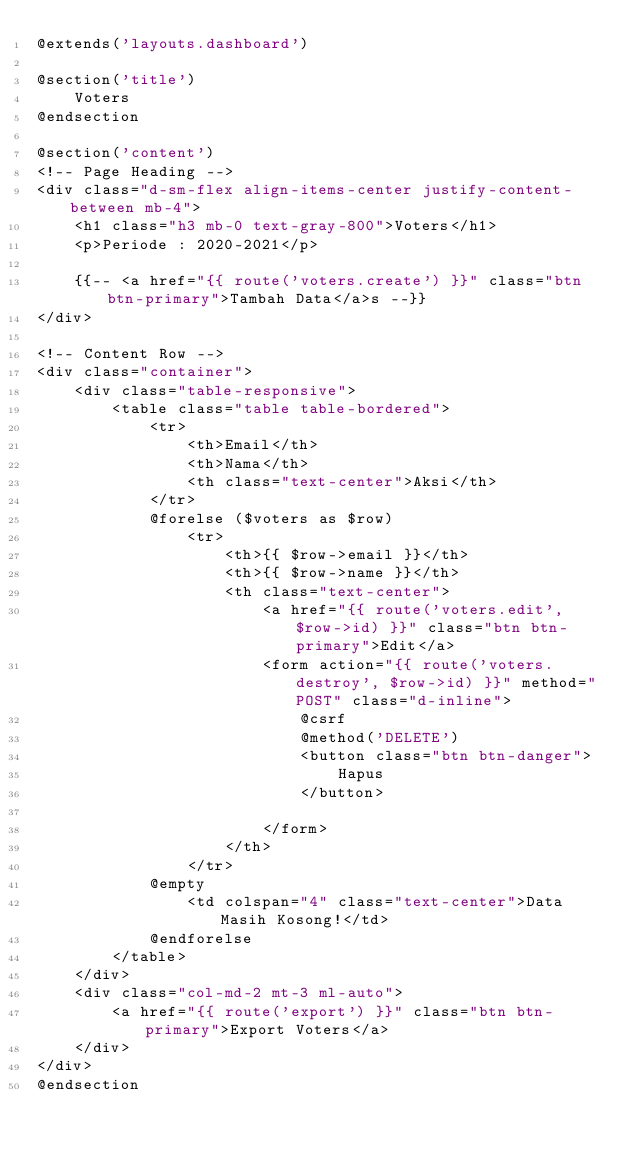<code> <loc_0><loc_0><loc_500><loc_500><_PHP_>@extends('layouts.dashboard')

@section('title')
    Voters
@endsection

@section('content')
<!-- Page Heading -->
<div class="d-sm-flex align-items-center justify-content-between mb-4">
    <h1 class="h3 mb-0 text-gray-800">Voters</h1>
    <p>Periode : 2020-2021</p>

    {{-- <a href="{{ route('voters.create') }}" class="btn btn-primary">Tambah Data</a>s --}}
</div>

<!-- Content Row -->
<div class="container">
    <div class="table-responsive">
        <table class="table table-bordered">
            <tr>
                <th>Email</th>
                <th>Nama</th>
                <th class="text-center">Aksi</th>
            </tr>
            @forelse ($voters as $row)
                <tr>
                    <th>{{ $row->email }}</th>
                    <th>{{ $row->name }}</th>
                    <th class="text-center"> 
                        <a href="{{ route('voters.edit', $row->id) }}" class="btn btn-primary">Edit</a>
                        <form action="{{ route('voters.destroy', $row->id) }}" method="POST" class="d-inline">
                            @csrf
                            @method('DELETE')
                            <button class="btn btn-danger">
                                Hapus
                            </button>

                        </form>
                    </th>
                </tr>
            @empty
                <td colspan="4" class="text-center">Data Masih Kosong!</td>
            @endforelse
        </table>
    </div>
    <div class="col-md-2 mt-3 ml-auto">
        <a href="{{ route('export') }}" class="btn btn-primary">Export Voters</a>
    </div>
</div>
@endsection</code> 